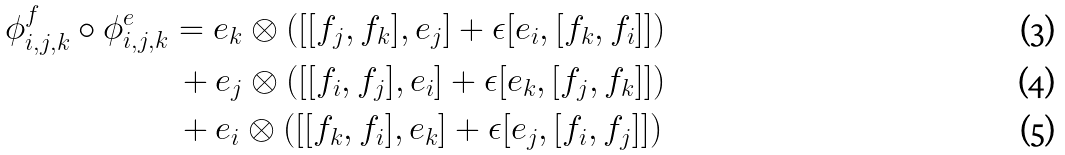<formula> <loc_0><loc_0><loc_500><loc_500>\phi ^ { f } _ { i , j , k } \circ \phi ^ { e } _ { i , j , k } & = e _ { k } \otimes ( [ [ f _ { j } , f _ { k } ] , e _ { j } ] + \epsilon [ e _ { i } , [ f _ { k } , f _ { i } ] ] ) \\ & \, + e _ { j } \otimes ( [ [ f _ { i } , f _ { j } ] , e _ { i } ] + \epsilon [ e _ { k } , [ f _ { j } , f _ { k } ] ] ) \\ & \, + e _ { i } \otimes ( [ [ f _ { k } , f _ { i } ] , e _ { k } ] + \epsilon [ e _ { j } , [ f _ { i } , f _ { j } ] ] )</formula> 